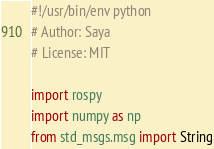Convert code to text. <code><loc_0><loc_0><loc_500><loc_500><_Python_>#!/usr/bin/env python
# Author: Saya
# License: MIT

import rospy
import numpy as np
from std_msgs.msg import String</code> 